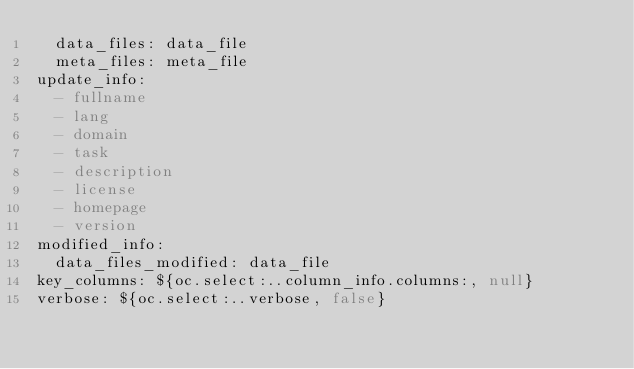<code> <loc_0><loc_0><loc_500><loc_500><_YAML_>  data_files: data_file
  meta_files: meta_file
update_info:
  - fullname
  - lang
  - domain
  - task
  - description
  - license
  - homepage
  - version
modified_info:
  data_files_modified: data_file
key_columns: ${oc.select:..column_info.columns:, null}
verbose: ${oc.select:..verbose, false}
</code> 